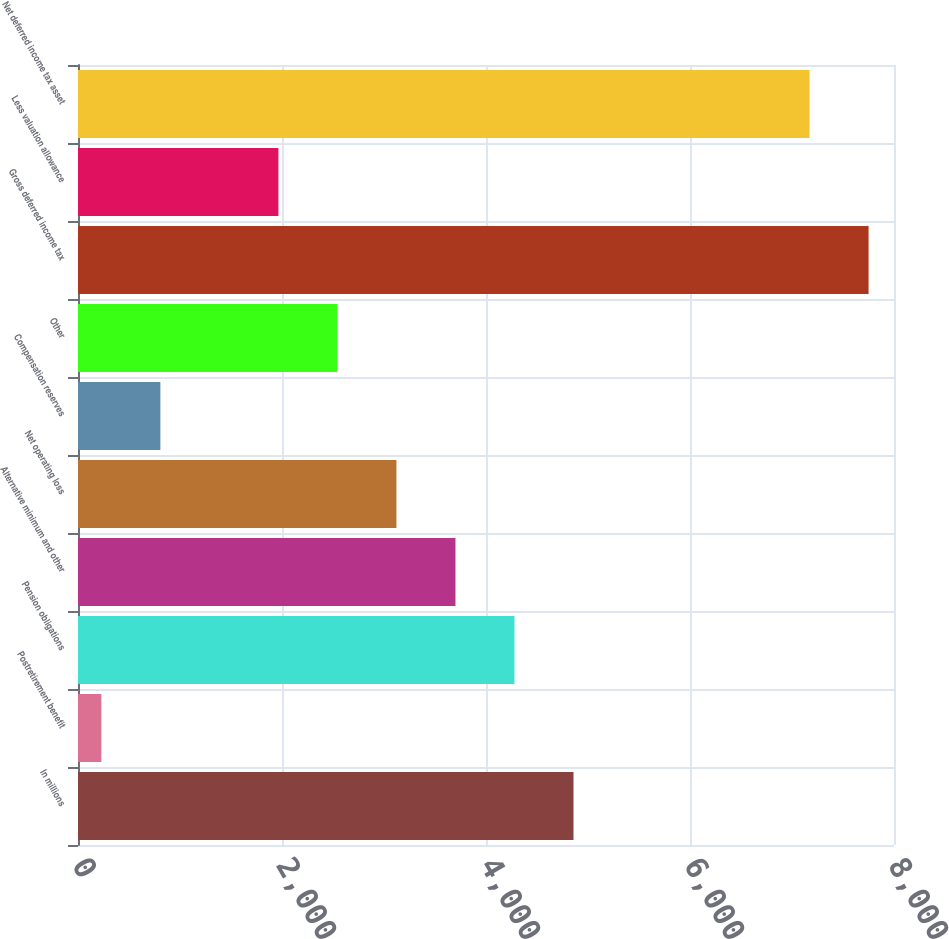Convert chart. <chart><loc_0><loc_0><loc_500><loc_500><bar_chart><fcel>In millions<fcel>Postretirement benefit<fcel>Pension obligations<fcel>Alternative minimum and other<fcel>Net operating loss<fcel>Compensation reserves<fcel>Other<fcel>Gross deferred income tax<fcel>Less valuation allowance<fcel>Net deferred income tax asset<nl><fcel>4857.8<fcel>229<fcel>4279.2<fcel>3700.6<fcel>3122<fcel>807.6<fcel>2543.4<fcel>7750.8<fcel>1964.8<fcel>7172.2<nl></chart> 